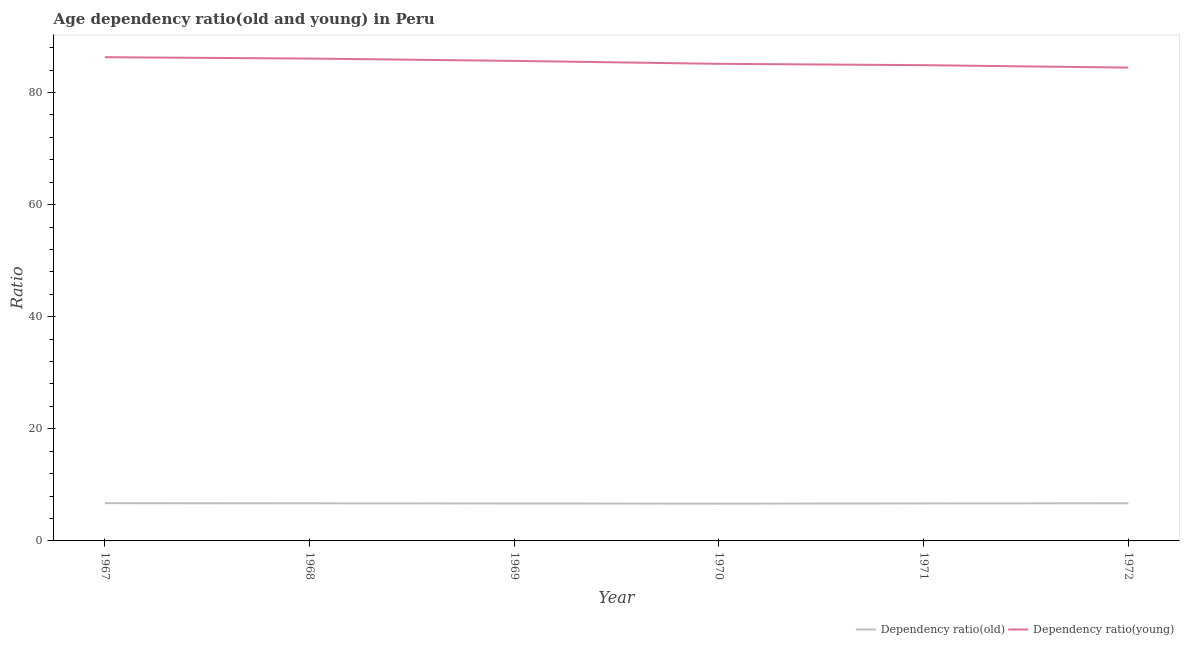How many different coloured lines are there?
Offer a very short reply. 2. Does the line corresponding to age dependency ratio(old) intersect with the line corresponding to age dependency ratio(young)?
Make the answer very short. No. Is the number of lines equal to the number of legend labels?
Provide a succinct answer. Yes. What is the age dependency ratio(old) in 1970?
Provide a succinct answer. 6.65. Across all years, what is the maximum age dependency ratio(old)?
Offer a very short reply. 6.73. Across all years, what is the minimum age dependency ratio(old)?
Your answer should be very brief. 6.65. In which year was the age dependency ratio(young) maximum?
Ensure brevity in your answer.  1967. What is the total age dependency ratio(young) in the graph?
Keep it short and to the point. 512.5. What is the difference between the age dependency ratio(young) in 1967 and that in 1970?
Make the answer very short. 1.18. What is the difference between the age dependency ratio(young) in 1971 and the age dependency ratio(old) in 1967?
Your answer should be very brief. 78.16. What is the average age dependency ratio(old) per year?
Ensure brevity in your answer.  6.7. In the year 1969, what is the difference between the age dependency ratio(young) and age dependency ratio(old)?
Make the answer very short. 78.97. What is the ratio of the age dependency ratio(young) in 1967 to that in 1968?
Offer a terse response. 1. Is the age dependency ratio(old) in 1967 less than that in 1968?
Your answer should be compact. No. Is the difference between the age dependency ratio(old) in 1967 and 1971 greater than the difference between the age dependency ratio(young) in 1967 and 1971?
Give a very brief answer. No. What is the difference between the highest and the second highest age dependency ratio(old)?
Offer a terse response. 0.02. What is the difference between the highest and the lowest age dependency ratio(old)?
Offer a terse response. 0.08. Does the age dependency ratio(old) monotonically increase over the years?
Provide a succinct answer. No. Is the age dependency ratio(young) strictly greater than the age dependency ratio(old) over the years?
Your answer should be compact. Yes. How many lines are there?
Provide a short and direct response. 2. How many years are there in the graph?
Provide a succinct answer. 6. Does the graph contain any zero values?
Ensure brevity in your answer.  No. How many legend labels are there?
Provide a short and direct response. 2. How are the legend labels stacked?
Offer a very short reply. Horizontal. What is the title of the graph?
Keep it short and to the point. Age dependency ratio(old and young) in Peru. Does "All education staff compensation" appear as one of the legend labels in the graph?
Offer a very short reply. No. What is the label or title of the Y-axis?
Keep it short and to the point. Ratio. What is the Ratio in Dependency ratio(old) in 1967?
Your response must be concise. 6.73. What is the Ratio of Dependency ratio(young) in 1967?
Your response must be concise. 86.31. What is the Ratio in Dependency ratio(old) in 1968?
Offer a very short reply. 6.71. What is the Ratio in Dependency ratio(young) in 1968?
Provide a succinct answer. 86.07. What is the Ratio in Dependency ratio(old) in 1969?
Offer a terse response. 6.68. What is the Ratio in Dependency ratio(young) in 1969?
Offer a very short reply. 85.65. What is the Ratio of Dependency ratio(old) in 1970?
Your answer should be compact. 6.65. What is the Ratio of Dependency ratio(young) in 1970?
Offer a terse response. 85.13. What is the Ratio in Dependency ratio(old) in 1971?
Make the answer very short. 6.69. What is the Ratio of Dependency ratio(young) in 1971?
Give a very brief answer. 84.89. What is the Ratio of Dependency ratio(old) in 1972?
Your response must be concise. 6.72. What is the Ratio in Dependency ratio(young) in 1972?
Provide a short and direct response. 84.45. Across all years, what is the maximum Ratio in Dependency ratio(old)?
Provide a short and direct response. 6.73. Across all years, what is the maximum Ratio in Dependency ratio(young)?
Make the answer very short. 86.31. Across all years, what is the minimum Ratio of Dependency ratio(old)?
Provide a succinct answer. 6.65. Across all years, what is the minimum Ratio of Dependency ratio(young)?
Give a very brief answer. 84.45. What is the total Ratio of Dependency ratio(old) in the graph?
Offer a very short reply. 40.19. What is the total Ratio of Dependency ratio(young) in the graph?
Ensure brevity in your answer.  512.5. What is the difference between the Ratio in Dependency ratio(old) in 1967 and that in 1968?
Offer a very short reply. 0.02. What is the difference between the Ratio of Dependency ratio(young) in 1967 and that in 1968?
Your response must be concise. 0.24. What is the difference between the Ratio in Dependency ratio(old) in 1967 and that in 1969?
Ensure brevity in your answer.  0.05. What is the difference between the Ratio of Dependency ratio(young) in 1967 and that in 1969?
Provide a short and direct response. 0.66. What is the difference between the Ratio of Dependency ratio(old) in 1967 and that in 1970?
Provide a succinct answer. 0.08. What is the difference between the Ratio in Dependency ratio(young) in 1967 and that in 1970?
Offer a terse response. 1.18. What is the difference between the Ratio of Dependency ratio(old) in 1967 and that in 1971?
Provide a succinct answer. 0.04. What is the difference between the Ratio in Dependency ratio(young) in 1967 and that in 1971?
Make the answer very short. 1.42. What is the difference between the Ratio of Dependency ratio(old) in 1967 and that in 1972?
Provide a succinct answer. 0.01. What is the difference between the Ratio in Dependency ratio(young) in 1967 and that in 1972?
Your answer should be very brief. 1.86. What is the difference between the Ratio of Dependency ratio(old) in 1968 and that in 1969?
Your response must be concise. 0.03. What is the difference between the Ratio in Dependency ratio(young) in 1968 and that in 1969?
Make the answer very short. 0.42. What is the difference between the Ratio of Dependency ratio(old) in 1968 and that in 1970?
Your answer should be compact. 0.06. What is the difference between the Ratio of Dependency ratio(young) in 1968 and that in 1970?
Give a very brief answer. 0.94. What is the difference between the Ratio in Dependency ratio(old) in 1968 and that in 1971?
Offer a terse response. 0.02. What is the difference between the Ratio in Dependency ratio(young) in 1968 and that in 1971?
Your answer should be compact. 1.18. What is the difference between the Ratio in Dependency ratio(old) in 1968 and that in 1972?
Ensure brevity in your answer.  -0.01. What is the difference between the Ratio in Dependency ratio(young) in 1968 and that in 1972?
Your response must be concise. 1.62. What is the difference between the Ratio in Dependency ratio(old) in 1969 and that in 1970?
Provide a short and direct response. 0.03. What is the difference between the Ratio of Dependency ratio(young) in 1969 and that in 1970?
Your answer should be compact. 0.52. What is the difference between the Ratio of Dependency ratio(old) in 1969 and that in 1971?
Offer a terse response. -0.01. What is the difference between the Ratio of Dependency ratio(young) in 1969 and that in 1971?
Your answer should be compact. 0.76. What is the difference between the Ratio in Dependency ratio(old) in 1969 and that in 1972?
Give a very brief answer. -0.04. What is the difference between the Ratio of Dependency ratio(young) in 1969 and that in 1972?
Your response must be concise. 1.2. What is the difference between the Ratio in Dependency ratio(old) in 1970 and that in 1971?
Your answer should be very brief. -0.04. What is the difference between the Ratio of Dependency ratio(young) in 1970 and that in 1971?
Make the answer very short. 0.24. What is the difference between the Ratio of Dependency ratio(old) in 1970 and that in 1972?
Offer a very short reply. -0.07. What is the difference between the Ratio in Dependency ratio(young) in 1970 and that in 1972?
Offer a very short reply. 0.68. What is the difference between the Ratio of Dependency ratio(old) in 1971 and that in 1972?
Give a very brief answer. -0.03. What is the difference between the Ratio in Dependency ratio(young) in 1971 and that in 1972?
Make the answer very short. 0.44. What is the difference between the Ratio in Dependency ratio(old) in 1967 and the Ratio in Dependency ratio(young) in 1968?
Your answer should be very brief. -79.33. What is the difference between the Ratio of Dependency ratio(old) in 1967 and the Ratio of Dependency ratio(young) in 1969?
Keep it short and to the point. -78.92. What is the difference between the Ratio of Dependency ratio(old) in 1967 and the Ratio of Dependency ratio(young) in 1970?
Your answer should be compact. -78.39. What is the difference between the Ratio of Dependency ratio(old) in 1967 and the Ratio of Dependency ratio(young) in 1971?
Offer a very short reply. -78.16. What is the difference between the Ratio of Dependency ratio(old) in 1967 and the Ratio of Dependency ratio(young) in 1972?
Provide a short and direct response. -77.72. What is the difference between the Ratio of Dependency ratio(old) in 1968 and the Ratio of Dependency ratio(young) in 1969?
Your answer should be compact. -78.94. What is the difference between the Ratio of Dependency ratio(old) in 1968 and the Ratio of Dependency ratio(young) in 1970?
Give a very brief answer. -78.42. What is the difference between the Ratio in Dependency ratio(old) in 1968 and the Ratio in Dependency ratio(young) in 1971?
Your answer should be compact. -78.18. What is the difference between the Ratio of Dependency ratio(old) in 1968 and the Ratio of Dependency ratio(young) in 1972?
Provide a succinct answer. -77.74. What is the difference between the Ratio in Dependency ratio(old) in 1969 and the Ratio in Dependency ratio(young) in 1970?
Make the answer very short. -78.45. What is the difference between the Ratio in Dependency ratio(old) in 1969 and the Ratio in Dependency ratio(young) in 1971?
Make the answer very short. -78.21. What is the difference between the Ratio in Dependency ratio(old) in 1969 and the Ratio in Dependency ratio(young) in 1972?
Offer a terse response. -77.77. What is the difference between the Ratio in Dependency ratio(old) in 1970 and the Ratio in Dependency ratio(young) in 1971?
Provide a short and direct response. -78.24. What is the difference between the Ratio in Dependency ratio(old) in 1970 and the Ratio in Dependency ratio(young) in 1972?
Offer a terse response. -77.8. What is the difference between the Ratio in Dependency ratio(old) in 1971 and the Ratio in Dependency ratio(young) in 1972?
Your answer should be compact. -77.76. What is the average Ratio in Dependency ratio(old) per year?
Your response must be concise. 6.7. What is the average Ratio in Dependency ratio(young) per year?
Give a very brief answer. 85.42. In the year 1967, what is the difference between the Ratio in Dependency ratio(old) and Ratio in Dependency ratio(young)?
Make the answer very short. -79.58. In the year 1968, what is the difference between the Ratio in Dependency ratio(old) and Ratio in Dependency ratio(young)?
Provide a short and direct response. -79.36. In the year 1969, what is the difference between the Ratio in Dependency ratio(old) and Ratio in Dependency ratio(young)?
Your response must be concise. -78.97. In the year 1970, what is the difference between the Ratio in Dependency ratio(old) and Ratio in Dependency ratio(young)?
Offer a terse response. -78.48. In the year 1971, what is the difference between the Ratio of Dependency ratio(old) and Ratio of Dependency ratio(young)?
Your answer should be compact. -78.2. In the year 1972, what is the difference between the Ratio in Dependency ratio(old) and Ratio in Dependency ratio(young)?
Offer a terse response. -77.73. What is the ratio of the Ratio in Dependency ratio(old) in 1967 to that in 1969?
Offer a very short reply. 1.01. What is the ratio of the Ratio in Dependency ratio(young) in 1967 to that in 1969?
Give a very brief answer. 1.01. What is the ratio of the Ratio of Dependency ratio(old) in 1967 to that in 1970?
Your answer should be very brief. 1.01. What is the ratio of the Ratio of Dependency ratio(young) in 1967 to that in 1970?
Your answer should be compact. 1.01. What is the ratio of the Ratio of Dependency ratio(old) in 1967 to that in 1971?
Your answer should be compact. 1.01. What is the ratio of the Ratio of Dependency ratio(young) in 1967 to that in 1971?
Your answer should be very brief. 1.02. What is the ratio of the Ratio in Dependency ratio(old) in 1967 to that in 1972?
Provide a short and direct response. 1. What is the ratio of the Ratio of Dependency ratio(old) in 1968 to that in 1970?
Ensure brevity in your answer.  1.01. What is the ratio of the Ratio of Dependency ratio(young) in 1968 to that in 1970?
Keep it short and to the point. 1.01. What is the ratio of the Ratio of Dependency ratio(young) in 1968 to that in 1971?
Your answer should be compact. 1.01. What is the ratio of the Ratio of Dependency ratio(old) in 1968 to that in 1972?
Give a very brief answer. 1. What is the ratio of the Ratio of Dependency ratio(young) in 1968 to that in 1972?
Keep it short and to the point. 1.02. What is the ratio of the Ratio of Dependency ratio(old) in 1969 to that in 1971?
Your answer should be compact. 1. What is the ratio of the Ratio in Dependency ratio(young) in 1969 to that in 1971?
Provide a short and direct response. 1.01. What is the ratio of the Ratio in Dependency ratio(young) in 1969 to that in 1972?
Your response must be concise. 1.01. What is the ratio of the Ratio in Dependency ratio(young) in 1970 to that in 1971?
Give a very brief answer. 1. What is the ratio of the Ratio of Dependency ratio(old) in 1970 to that in 1972?
Provide a succinct answer. 0.99. What is the ratio of the Ratio of Dependency ratio(old) in 1971 to that in 1972?
Your answer should be very brief. 1. What is the ratio of the Ratio of Dependency ratio(young) in 1971 to that in 1972?
Your answer should be very brief. 1.01. What is the difference between the highest and the second highest Ratio in Dependency ratio(old)?
Your answer should be compact. 0.01. What is the difference between the highest and the second highest Ratio in Dependency ratio(young)?
Provide a succinct answer. 0.24. What is the difference between the highest and the lowest Ratio of Dependency ratio(old)?
Offer a very short reply. 0.08. What is the difference between the highest and the lowest Ratio of Dependency ratio(young)?
Offer a very short reply. 1.86. 